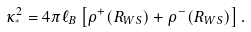<formula> <loc_0><loc_0><loc_500><loc_500>\kappa ^ { 2 } _ { ^ { * } } = 4 \pi \ell _ { B } \left [ \rho ^ { + } ( R _ { W S } ) + \rho ^ { - } ( R _ { W S } ) \right ] .</formula> 